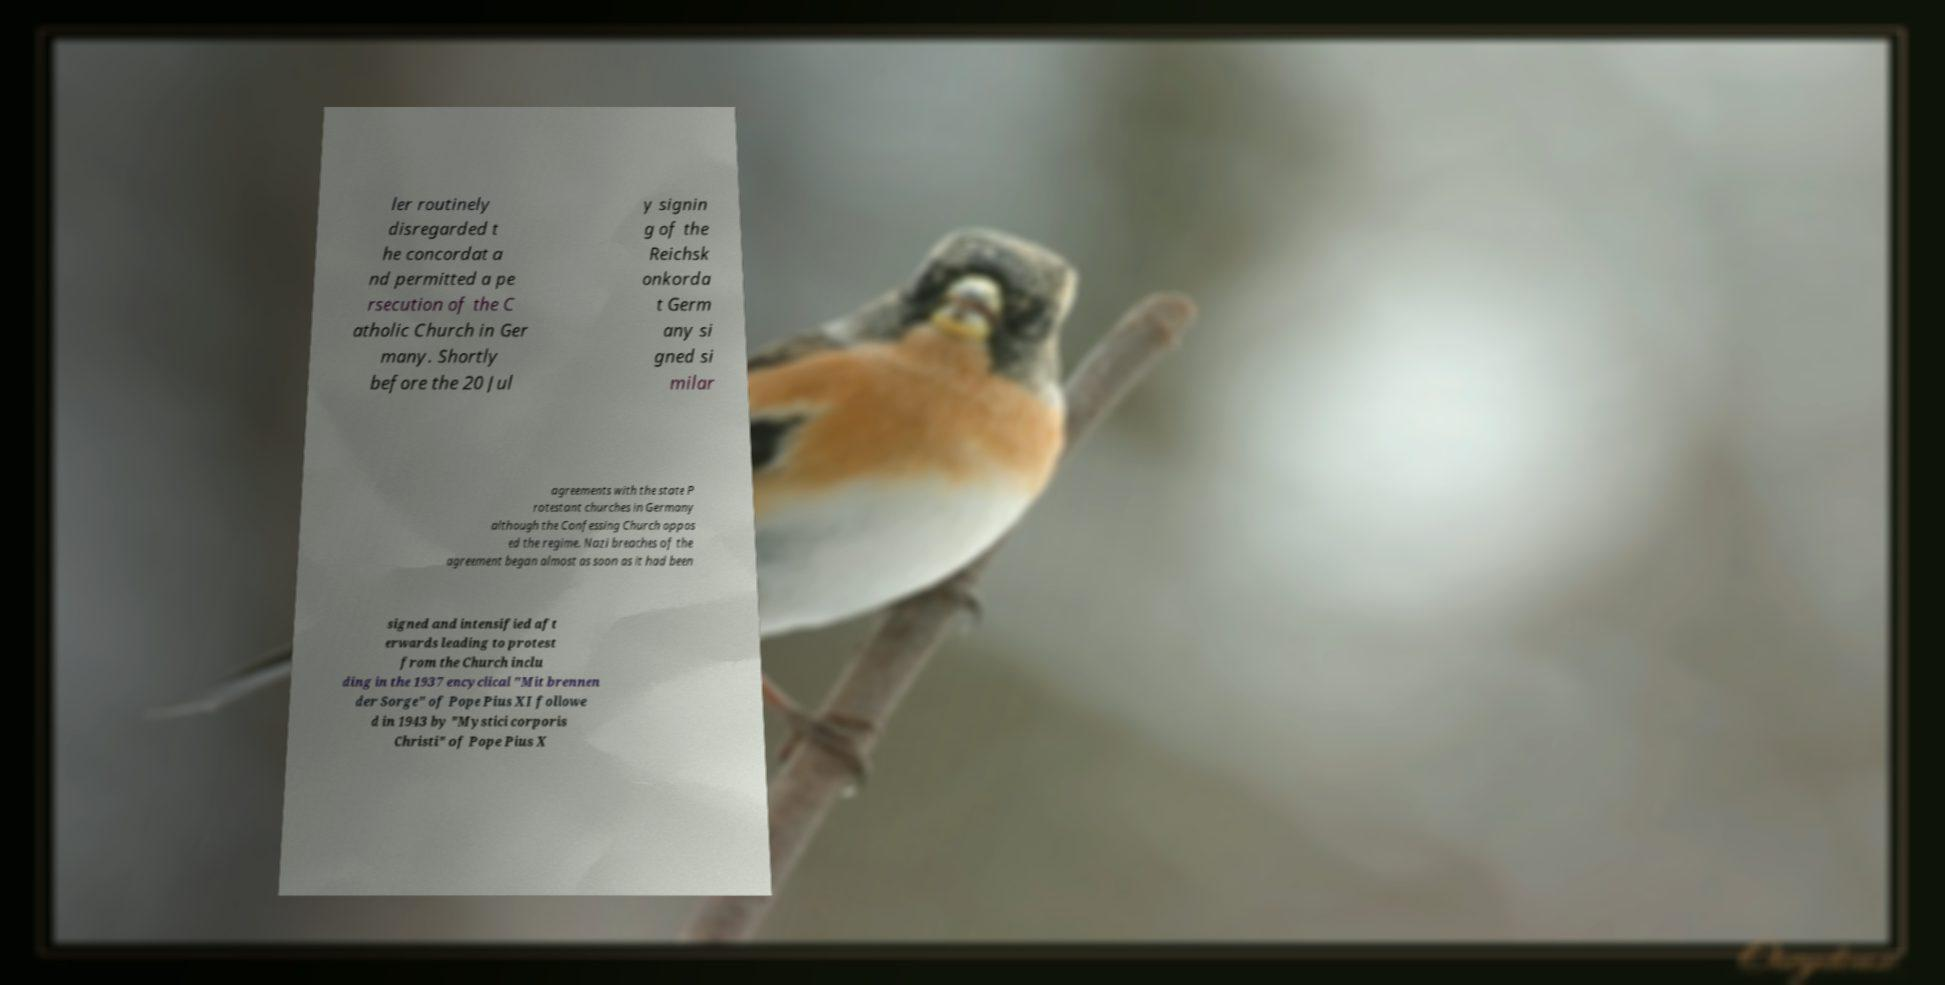Can you read and provide the text displayed in the image?This photo seems to have some interesting text. Can you extract and type it out for me? ler routinely disregarded t he concordat a nd permitted a pe rsecution of the C atholic Church in Ger many. Shortly before the 20 Jul y signin g of the Reichsk onkorda t Germ any si gned si milar agreements with the state P rotestant churches in Germany although the Confessing Church oppos ed the regime. Nazi breaches of the agreement began almost as soon as it had been signed and intensified aft erwards leading to protest from the Church inclu ding in the 1937 encyclical "Mit brennen der Sorge" of Pope Pius XI followe d in 1943 by "Mystici corporis Christi" of Pope Pius X 